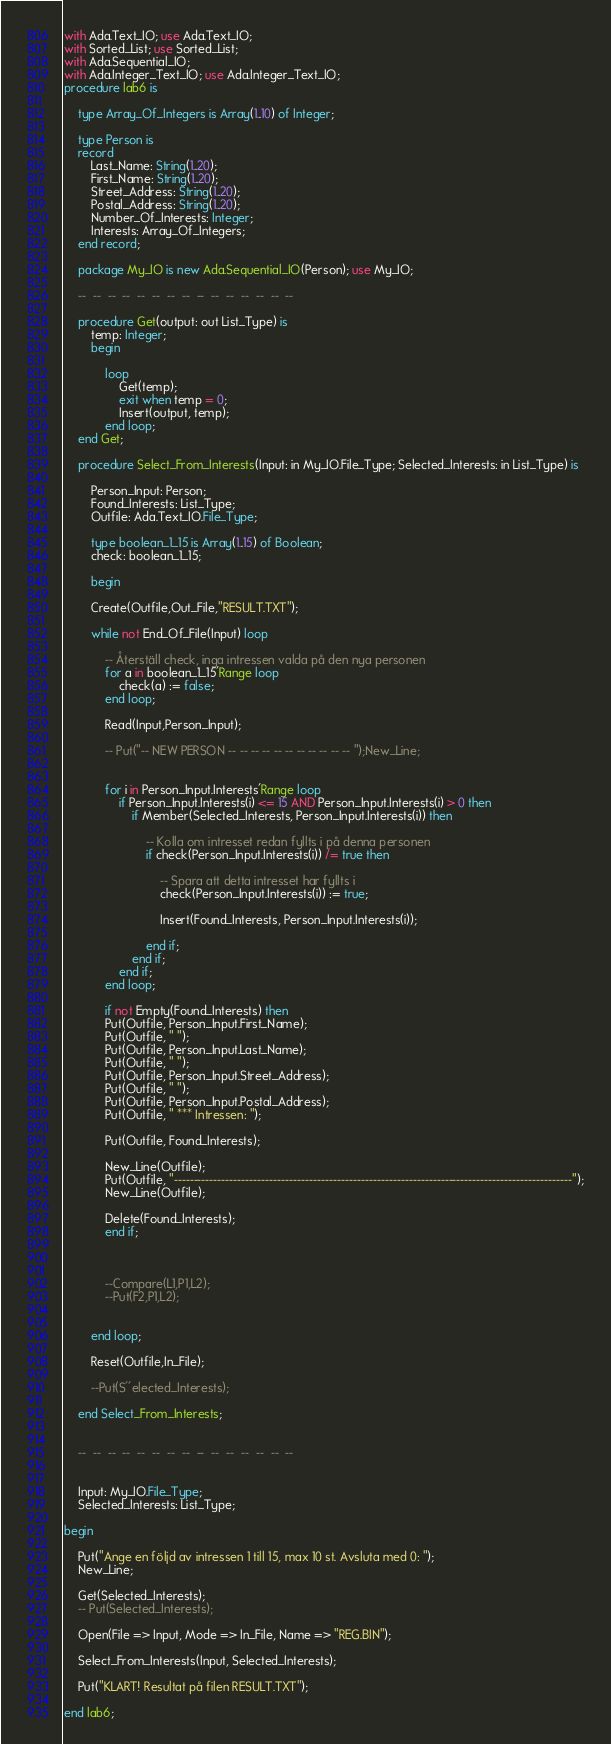<code> <loc_0><loc_0><loc_500><loc_500><_Ada_>with Ada.Text_IO; use Ada.Text_IO;
with Sorted_List; use Sorted_List;
with Ada.Sequential_IO;
with Ada.Integer_Text_IO; use Ada.Integer_Text_IO;
procedure lab6 is

	type Array_Of_Integers is Array(1..10) of Integer;

	type Person is
	record
		Last_Name: String(1..20);
		First_Name: String(1..20);
		Street_Address: String(1..20);
		Postal_Address: String(1..20);
		Number_Of_Interests: Integer;
		Interests: Array_Of_Integers;
	end record;

	package My_IO is new Ada.Sequential_IO(Person); use My_IO;

	--  --  --  --  --  --  --  --  --  --  --  --  --  --  --

	procedure Get(output: out List_Type) is
		temp: Integer;
		begin

			loop
				Get(temp);
				exit when temp = 0;
				Insert(output, temp);
			end loop;
	end Get;

	procedure Select_From_Interests(Input: in My_IO.File_Type; Selected_Interests: in List_Type) is 

		Person_Input: Person;
		Found_Interests: List_Type;
		Outfile: Ada.Text_IO.File_Type;

		type boolean_1_15 is Array(1..15) of Boolean;
		check: boolean_1_15;

		begin

		Create(Outfile,Out_File,"RESULT.TXT");

		while not End_Of_File(Input) loop

			-- Återställ check, inga intressen valda på den nya personen
			for a in boolean_1_15'Range loop
				check(a) := false;
			end loop;

			Read(Input,Person_Input);

			-- Put("-- NEW PERSON -- -- -- -- -- -- -- -- -- -- -- ");New_Line;


			for i in Person_Input.Interests'Range loop
				if Person_Input.Interests(i) <= 15 AND Person_Input.Interests(i) > 0 then
					if Member(Selected_Interests, Person_Input.Interests(i)) then
						
						-- Kolla om intresset redan fyllts i på denna personen
						if check(Person_Input.Interests(i)) /= true then
							
							-- Spara att detta intresset har fyllts i
							check(Person_Input.Interests(i)) := true;

							Insert(Found_Interests, Person_Input.Interests(i));

						end if;
					end if;
				end if;
			end loop;

			if not Empty(Found_Interests) then
			Put(Outfile, Person_Input.First_Name);
			Put(Outfile, " ");
			Put(Outfile, Person_Input.Last_Name);
			Put(Outfile, " ");
			Put(Outfile, Person_Input.Street_Address);
			Put(Outfile, " ");
			Put(Outfile, Person_Input.Postal_Address);
			Put(Outfile, " *** Intressen: ");

			Put(Outfile, Found_Interests);

			New_Line(Outfile);
			Put(Outfile, "----------------------------------------------------------------------------------------------------");
			New_Line(Outfile);

			Delete(Found_Interests);
			end if;
			


			--Compare(L1,P1,L2);
			--Put(F2,P1,L2); 


		end loop;

		Reset(Outfile,In_File);

		--Put(S''elected_Interests);

	end Select_From_Interests;


	--  --  --  --  --  --  --  --  --  --  --  --  --  --  --


	Input: My_IO.File_Type;
	Selected_Interests: List_Type;

begin

	Put("Ange en följd av intressen 1 till 15, max 10 st. Avsluta med 0: ");
	New_Line;
	
	Get(Selected_Interests);
	-- Put(Selected_Interests);
	
	Open(File => Input, Mode => In_File, Name => "REG.BIN");

	Select_From_Interests(Input, Selected_Interests);

	Put("KLART! Resultat på filen RESULT.TXT");

end lab6;
</code> 